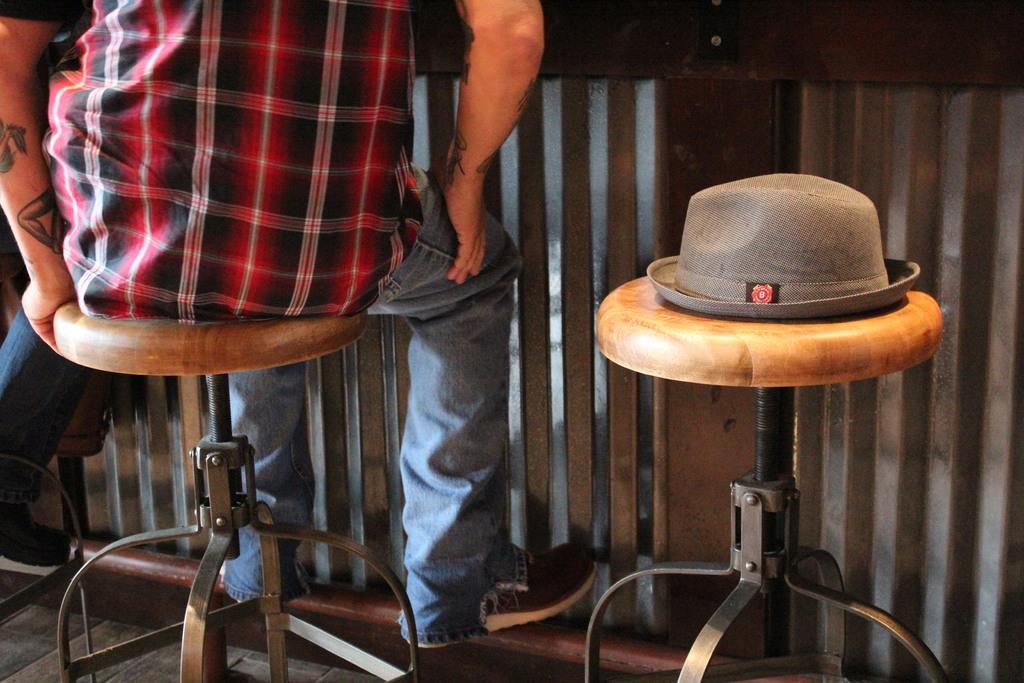Describe this image in one or two sentences. A person wearing a black and red shirt is sitting on a stool. And beside him there is an another stool, there is a hat. 